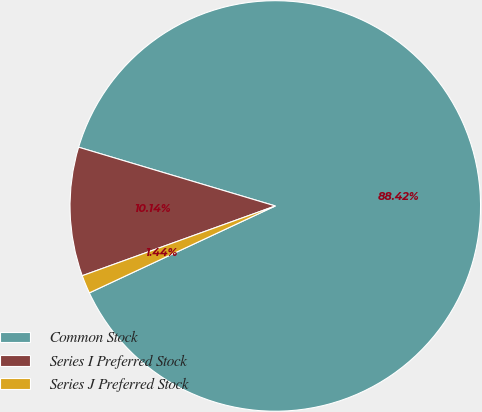Convert chart. <chart><loc_0><loc_0><loc_500><loc_500><pie_chart><fcel>Common Stock<fcel>Series I Preferred Stock<fcel>Series J Preferred Stock<nl><fcel>88.42%<fcel>10.14%<fcel>1.44%<nl></chart> 